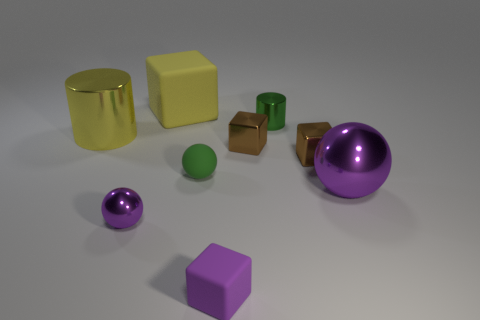Are there more metal spheres than small cylinders?
Provide a short and direct response. Yes. Is there a green cylinder that has the same size as the yellow block?
Offer a terse response. No. How many things are matte cubes in front of the small purple metal object or shiny objects right of the small purple sphere?
Give a very brief answer. 5. What color is the small rubber object on the left side of the matte block that is in front of the small purple ball?
Ensure brevity in your answer.  Green. There is a small ball that is the same material as the large cube; what is its color?
Give a very brief answer. Green. What number of big rubber cubes are the same color as the big metallic sphere?
Ensure brevity in your answer.  0. How many things are metallic cylinders or tiny green things?
Make the answer very short. 3. The purple rubber object that is the same size as the green rubber ball is what shape?
Your response must be concise. Cube. What number of objects are both on the left side of the large purple shiny ball and in front of the large yellow shiny cylinder?
Give a very brief answer. 5. What is the ball that is to the left of the green matte ball made of?
Keep it short and to the point. Metal. 